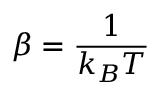Convert formula to latex. <formula><loc_0><loc_0><loc_500><loc_500>\beta = \frac { 1 } { k _ { B } T }</formula> 